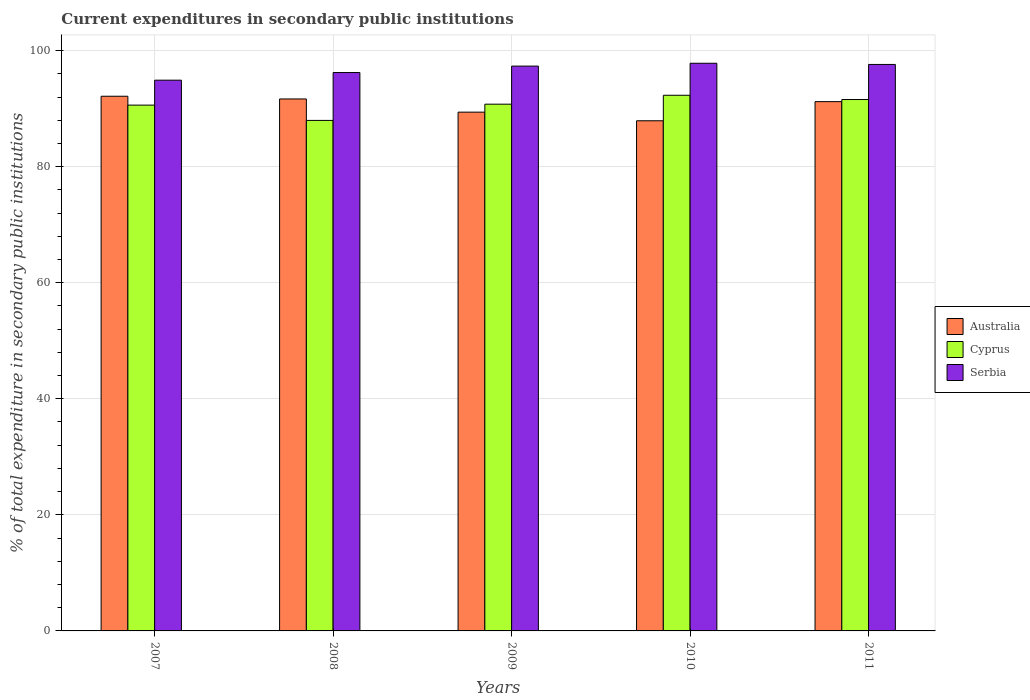Are the number of bars per tick equal to the number of legend labels?
Provide a succinct answer. Yes. How many bars are there on the 2nd tick from the left?
Your answer should be very brief. 3. What is the current expenditures in secondary public institutions in Cyprus in 2007?
Provide a short and direct response. 90.6. Across all years, what is the maximum current expenditures in secondary public institutions in Cyprus?
Ensure brevity in your answer.  92.3. Across all years, what is the minimum current expenditures in secondary public institutions in Australia?
Ensure brevity in your answer.  87.91. In which year was the current expenditures in secondary public institutions in Cyprus minimum?
Your answer should be very brief. 2008. What is the total current expenditures in secondary public institutions in Cyprus in the graph?
Offer a very short reply. 453.19. What is the difference between the current expenditures in secondary public institutions in Cyprus in 2008 and that in 2011?
Offer a very short reply. -3.6. What is the difference between the current expenditures in secondary public institutions in Serbia in 2011 and the current expenditures in secondary public institutions in Australia in 2009?
Your response must be concise. 8.22. What is the average current expenditures in secondary public institutions in Serbia per year?
Your answer should be very brief. 96.77. In the year 2011, what is the difference between the current expenditures in secondary public institutions in Cyprus and current expenditures in secondary public institutions in Australia?
Give a very brief answer. 0.36. What is the ratio of the current expenditures in secondary public institutions in Australia in 2007 to that in 2008?
Offer a terse response. 1.01. What is the difference between the highest and the second highest current expenditures in secondary public institutions in Cyprus?
Your response must be concise. 0.73. What is the difference between the highest and the lowest current expenditures in secondary public institutions in Serbia?
Your answer should be compact. 2.92. What does the 2nd bar from the left in 2009 represents?
Offer a very short reply. Cyprus. How many bars are there?
Provide a succinct answer. 15. How many years are there in the graph?
Give a very brief answer. 5. Are the values on the major ticks of Y-axis written in scientific E-notation?
Keep it short and to the point. No. Does the graph contain any zero values?
Make the answer very short. No. Does the graph contain grids?
Offer a terse response. Yes. How are the legend labels stacked?
Make the answer very short. Vertical. What is the title of the graph?
Ensure brevity in your answer.  Current expenditures in secondary public institutions. What is the label or title of the Y-axis?
Offer a very short reply. % of total expenditure in secondary public institutions. What is the % of total expenditure in secondary public institutions in Australia in 2007?
Your answer should be very brief. 92.13. What is the % of total expenditure in secondary public institutions of Cyprus in 2007?
Keep it short and to the point. 90.6. What is the % of total expenditure in secondary public institutions in Serbia in 2007?
Your answer should be very brief. 94.9. What is the % of total expenditure in secondary public institutions in Australia in 2008?
Make the answer very short. 91.66. What is the % of total expenditure in secondary public institutions in Cyprus in 2008?
Provide a succinct answer. 87.97. What is the % of total expenditure in secondary public institutions in Serbia in 2008?
Provide a short and direct response. 96.22. What is the % of total expenditure in secondary public institutions of Australia in 2009?
Offer a terse response. 89.39. What is the % of total expenditure in secondary public institutions in Cyprus in 2009?
Your response must be concise. 90.76. What is the % of total expenditure in secondary public institutions in Serbia in 2009?
Your answer should be very brief. 97.32. What is the % of total expenditure in secondary public institutions in Australia in 2010?
Your answer should be very brief. 87.91. What is the % of total expenditure in secondary public institutions in Cyprus in 2010?
Your answer should be very brief. 92.3. What is the % of total expenditure in secondary public institutions in Serbia in 2010?
Provide a succinct answer. 97.81. What is the % of total expenditure in secondary public institutions of Australia in 2011?
Your response must be concise. 91.2. What is the % of total expenditure in secondary public institutions in Cyprus in 2011?
Provide a succinct answer. 91.57. What is the % of total expenditure in secondary public institutions in Serbia in 2011?
Make the answer very short. 97.61. Across all years, what is the maximum % of total expenditure in secondary public institutions of Australia?
Ensure brevity in your answer.  92.13. Across all years, what is the maximum % of total expenditure in secondary public institutions in Cyprus?
Offer a terse response. 92.3. Across all years, what is the maximum % of total expenditure in secondary public institutions in Serbia?
Provide a succinct answer. 97.81. Across all years, what is the minimum % of total expenditure in secondary public institutions of Australia?
Offer a terse response. 87.91. Across all years, what is the minimum % of total expenditure in secondary public institutions of Cyprus?
Your response must be concise. 87.97. Across all years, what is the minimum % of total expenditure in secondary public institutions of Serbia?
Your answer should be compact. 94.9. What is the total % of total expenditure in secondary public institutions in Australia in the graph?
Make the answer very short. 452.29. What is the total % of total expenditure in secondary public institutions in Cyprus in the graph?
Keep it short and to the point. 453.19. What is the total % of total expenditure in secondary public institutions in Serbia in the graph?
Give a very brief answer. 483.86. What is the difference between the % of total expenditure in secondary public institutions of Australia in 2007 and that in 2008?
Offer a very short reply. 0.47. What is the difference between the % of total expenditure in secondary public institutions in Cyprus in 2007 and that in 2008?
Give a very brief answer. 2.64. What is the difference between the % of total expenditure in secondary public institutions of Serbia in 2007 and that in 2008?
Give a very brief answer. -1.32. What is the difference between the % of total expenditure in secondary public institutions of Australia in 2007 and that in 2009?
Offer a very short reply. 2.74. What is the difference between the % of total expenditure in secondary public institutions of Cyprus in 2007 and that in 2009?
Ensure brevity in your answer.  -0.16. What is the difference between the % of total expenditure in secondary public institutions of Serbia in 2007 and that in 2009?
Offer a very short reply. -2.42. What is the difference between the % of total expenditure in secondary public institutions in Australia in 2007 and that in 2010?
Give a very brief answer. 4.23. What is the difference between the % of total expenditure in secondary public institutions of Cyprus in 2007 and that in 2010?
Provide a short and direct response. -1.7. What is the difference between the % of total expenditure in secondary public institutions of Serbia in 2007 and that in 2010?
Your answer should be compact. -2.92. What is the difference between the % of total expenditure in secondary public institutions in Australia in 2007 and that in 2011?
Offer a very short reply. 0.93. What is the difference between the % of total expenditure in secondary public institutions in Cyprus in 2007 and that in 2011?
Your answer should be very brief. -0.96. What is the difference between the % of total expenditure in secondary public institutions of Serbia in 2007 and that in 2011?
Ensure brevity in your answer.  -2.71. What is the difference between the % of total expenditure in secondary public institutions in Australia in 2008 and that in 2009?
Provide a short and direct response. 2.27. What is the difference between the % of total expenditure in secondary public institutions of Cyprus in 2008 and that in 2009?
Your response must be concise. -2.8. What is the difference between the % of total expenditure in secondary public institutions in Serbia in 2008 and that in 2009?
Give a very brief answer. -1.11. What is the difference between the % of total expenditure in secondary public institutions in Australia in 2008 and that in 2010?
Make the answer very short. 3.76. What is the difference between the % of total expenditure in secondary public institutions in Cyprus in 2008 and that in 2010?
Give a very brief answer. -4.33. What is the difference between the % of total expenditure in secondary public institutions in Serbia in 2008 and that in 2010?
Your answer should be compact. -1.6. What is the difference between the % of total expenditure in secondary public institutions in Australia in 2008 and that in 2011?
Your answer should be very brief. 0.46. What is the difference between the % of total expenditure in secondary public institutions of Cyprus in 2008 and that in 2011?
Offer a terse response. -3.6. What is the difference between the % of total expenditure in secondary public institutions in Serbia in 2008 and that in 2011?
Provide a succinct answer. -1.39. What is the difference between the % of total expenditure in secondary public institutions of Australia in 2009 and that in 2010?
Provide a short and direct response. 1.49. What is the difference between the % of total expenditure in secondary public institutions of Cyprus in 2009 and that in 2010?
Ensure brevity in your answer.  -1.54. What is the difference between the % of total expenditure in secondary public institutions of Serbia in 2009 and that in 2010?
Provide a short and direct response. -0.49. What is the difference between the % of total expenditure in secondary public institutions in Australia in 2009 and that in 2011?
Provide a short and direct response. -1.81. What is the difference between the % of total expenditure in secondary public institutions in Cyprus in 2009 and that in 2011?
Provide a short and direct response. -0.8. What is the difference between the % of total expenditure in secondary public institutions of Serbia in 2009 and that in 2011?
Offer a very short reply. -0.29. What is the difference between the % of total expenditure in secondary public institutions of Australia in 2010 and that in 2011?
Keep it short and to the point. -3.3. What is the difference between the % of total expenditure in secondary public institutions of Cyprus in 2010 and that in 2011?
Your answer should be very brief. 0.73. What is the difference between the % of total expenditure in secondary public institutions of Serbia in 2010 and that in 2011?
Make the answer very short. 0.21. What is the difference between the % of total expenditure in secondary public institutions of Australia in 2007 and the % of total expenditure in secondary public institutions of Cyprus in 2008?
Provide a succinct answer. 4.17. What is the difference between the % of total expenditure in secondary public institutions of Australia in 2007 and the % of total expenditure in secondary public institutions of Serbia in 2008?
Provide a succinct answer. -4.09. What is the difference between the % of total expenditure in secondary public institutions in Cyprus in 2007 and the % of total expenditure in secondary public institutions in Serbia in 2008?
Provide a short and direct response. -5.62. What is the difference between the % of total expenditure in secondary public institutions in Australia in 2007 and the % of total expenditure in secondary public institutions in Cyprus in 2009?
Ensure brevity in your answer.  1.37. What is the difference between the % of total expenditure in secondary public institutions in Australia in 2007 and the % of total expenditure in secondary public institutions in Serbia in 2009?
Give a very brief answer. -5.19. What is the difference between the % of total expenditure in secondary public institutions of Cyprus in 2007 and the % of total expenditure in secondary public institutions of Serbia in 2009?
Provide a succinct answer. -6.72. What is the difference between the % of total expenditure in secondary public institutions of Australia in 2007 and the % of total expenditure in secondary public institutions of Cyprus in 2010?
Your response must be concise. -0.17. What is the difference between the % of total expenditure in secondary public institutions of Australia in 2007 and the % of total expenditure in secondary public institutions of Serbia in 2010?
Your response must be concise. -5.68. What is the difference between the % of total expenditure in secondary public institutions of Cyprus in 2007 and the % of total expenditure in secondary public institutions of Serbia in 2010?
Make the answer very short. -7.21. What is the difference between the % of total expenditure in secondary public institutions in Australia in 2007 and the % of total expenditure in secondary public institutions in Cyprus in 2011?
Keep it short and to the point. 0.57. What is the difference between the % of total expenditure in secondary public institutions in Australia in 2007 and the % of total expenditure in secondary public institutions in Serbia in 2011?
Your answer should be very brief. -5.48. What is the difference between the % of total expenditure in secondary public institutions in Cyprus in 2007 and the % of total expenditure in secondary public institutions in Serbia in 2011?
Give a very brief answer. -7.01. What is the difference between the % of total expenditure in secondary public institutions of Australia in 2008 and the % of total expenditure in secondary public institutions of Cyprus in 2009?
Your response must be concise. 0.9. What is the difference between the % of total expenditure in secondary public institutions in Australia in 2008 and the % of total expenditure in secondary public institutions in Serbia in 2009?
Keep it short and to the point. -5.66. What is the difference between the % of total expenditure in secondary public institutions of Cyprus in 2008 and the % of total expenditure in secondary public institutions of Serbia in 2009?
Provide a succinct answer. -9.36. What is the difference between the % of total expenditure in secondary public institutions of Australia in 2008 and the % of total expenditure in secondary public institutions of Cyprus in 2010?
Your answer should be compact. -0.64. What is the difference between the % of total expenditure in secondary public institutions in Australia in 2008 and the % of total expenditure in secondary public institutions in Serbia in 2010?
Give a very brief answer. -6.15. What is the difference between the % of total expenditure in secondary public institutions in Cyprus in 2008 and the % of total expenditure in secondary public institutions in Serbia in 2010?
Make the answer very short. -9.85. What is the difference between the % of total expenditure in secondary public institutions of Australia in 2008 and the % of total expenditure in secondary public institutions of Cyprus in 2011?
Your answer should be compact. 0.1. What is the difference between the % of total expenditure in secondary public institutions in Australia in 2008 and the % of total expenditure in secondary public institutions in Serbia in 2011?
Provide a short and direct response. -5.95. What is the difference between the % of total expenditure in secondary public institutions of Cyprus in 2008 and the % of total expenditure in secondary public institutions of Serbia in 2011?
Provide a succinct answer. -9.64. What is the difference between the % of total expenditure in secondary public institutions in Australia in 2009 and the % of total expenditure in secondary public institutions in Cyprus in 2010?
Ensure brevity in your answer.  -2.91. What is the difference between the % of total expenditure in secondary public institutions of Australia in 2009 and the % of total expenditure in secondary public institutions of Serbia in 2010?
Keep it short and to the point. -8.42. What is the difference between the % of total expenditure in secondary public institutions of Cyprus in 2009 and the % of total expenditure in secondary public institutions of Serbia in 2010?
Offer a very short reply. -7.05. What is the difference between the % of total expenditure in secondary public institutions of Australia in 2009 and the % of total expenditure in secondary public institutions of Cyprus in 2011?
Your answer should be compact. -2.17. What is the difference between the % of total expenditure in secondary public institutions in Australia in 2009 and the % of total expenditure in secondary public institutions in Serbia in 2011?
Your response must be concise. -8.22. What is the difference between the % of total expenditure in secondary public institutions in Cyprus in 2009 and the % of total expenditure in secondary public institutions in Serbia in 2011?
Offer a terse response. -6.85. What is the difference between the % of total expenditure in secondary public institutions in Australia in 2010 and the % of total expenditure in secondary public institutions in Cyprus in 2011?
Keep it short and to the point. -3.66. What is the difference between the % of total expenditure in secondary public institutions of Australia in 2010 and the % of total expenditure in secondary public institutions of Serbia in 2011?
Your answer should be compact. -9.7. What is the difference between the % of total expenditure in secondary public institutions of Cyprus in 2010 and the % of total expenditure in secondary public institutions of Serbia in 2011?
Keep it short and to the point. -5.31. What is the average % of total expenditure in secondary public institutions of Australia per year?
Keep it short and to the point. 90.46. What is the average % of total expenditure in secondary public institutions in Cyprus per year?
Your answer should be very brief. 90.64. What is the average % of total expenditure in secondary public institutions of Serbia per year?
Your answer should be very brief. 96.77. In the year 2007, what is the difference between the % of total expenditure in secondary public institutions in Australia and % of total expenditure in secondary public institutions in Cyprus?
Keep it short and to the point. 1.53. In the year 2007, what is the difference between the % of total expenditure in secondary public institutions in Australia and % of total expenditure in secondary public institutions in Serbia?
Your answer should be very brief. -2.77. In the year 2007, what is the difference between the % of total expenditure in secondary public institutions of Cyprus and % of total expenditure in secondary public institutions of Serbia?
Your answer should be very brief. -4.3. In the year 2008, what is the difference between the % of total expenditure in secondary public institutions of Australia and % of total expenditure in secondary public institutions of Cyprus?
Make the answer very short. 3.7. In the year 2008, what is the difference between the % of total expenditure in secondary public institutions in Australia and % of total expenditure in secondary public institutions in Serbia?
Offer a very short reply. -4.55. In the year 2008, what is the difference between the % of total expenditure in secondary public institutions of Cyprus and % of total expenditure in secondary public institutions of Serbia?
Provide a succinct answer. -8.25. In the year 2009, what is the difference between the % of total expenditure in secondary public institutions in Australia and % of total expenditure in secondary public institutions in Cyprus?
Provide a succinct answer. -1.37. In the year 2009, what is the difference between the % of total expenditure in secondary public institutions of Australia and % of total expenditure in secondary public institutions of Serbia?
Give a very brief answer. -7.93. In the year 2009, what is the difference between the % of total expenditure in secondary public institutions in Cyprus and % of total expenditure in secondary public institutions in Serbia?
Make the answer very short. -6.56. In the year 2010, what is the difference between the % of total expenditure in secondary public institutions of Australia and % of total expenditure in secondary public institutions of Cyprus?
Provide a short and direct response. -4.39. In the year 2010, what is the difference between the % of total expenditure in secondary public institutions in Australia and % of total expenditure in secondary public institutions in Serbia?
Give a very brief answer. -9.91. In the year 2010, what is the difference between the % of total expenditure in secondary public institutions of Cyprus and % of total expenditure in secondary public institutions of Serbia?
Give a very brief answer. -5.52. In the year 2011, what is the difference between the % of total expenditure in secondary public institutions in Australia and % of total expenditure in secondary public institutions in Cyprus?
Provide a short and direct response. -0.36. In the year 2011, what is the difference between the % of total expenditure in secondary public institutions of Australia and % of total expenditure in secondary public institutions of Serbia?
Make the answer very short. -6.41. In the year 2011, what is the difference between the % of total expenditure in secondary public institutions of Cyprus and % of total expenditure in secondary public institutions of Serbia?
Your answer should be compact. -6.04. What is the ratio of the % of total expenditure in secondary public institutions of Cyprus in 2007 to that in 2008?
Your answer should be very brief. 1.03. What is the ratio of the % of total expenditure in secondary public institutions in Serbia in 2007 to that in 2008?
Keep it short and to the point. 0.99. What is the ratio of the % of total expenditure in secondary public institutions in Australia in 2007 to that in 2009?
Keep it short and to the point. 1.03. What is the ratio of the % of total expenditure in secondary public institutions of Serbia in 2007 to that in 2009?
Your answer should be very brief. 0.98. What is the ratio of the % of total expenditure in secondary public institutions of Australia in 2007 to that in 2010?
Provide a succinct answer. 1.05. What is the ratio of the % of total expenditure in secondary public institutions in Cyprus in 2007 to that in 2010?
Offer a very short reply. 0.98. What is the ratio of the % of total expenditure in secondary public institutions of Serbia in 2007 to that in 2010?
Ensure brevity in your answer.  0.97. What is the ratio of the % of total expenditure in secondary public institutions in Australia in 2007 to that in 2011?
Give a very brief answer. 1.01. What is the ratio of the % of total expenditure in secondary public institutions of Serbia in 2007 to that in 2011?
Give a very brief answer. 0.97. What is the ratio of the % of total expenditure in secondary public institutions in Australia in 2008 to that in 2009?
Provide a succinct answer. 1.03. What is the ratio of the % of total expenditure in secondary public institutions in Cyprus in 2008 to that in 2009?
Your answer should be compact. 0.97. What is the ratio of the % of total expenditure in secondary public institutions in Australia in 2008 to that in 2010?
Provide a short and direct response. 1.04. What is the ratio of the % of total expenditure in secondary public institutions of Cyprus in 2008 to that in 2010?
Your answer should be very brief. 0.95. What is the ratio of the % of total expenditure in secondary public institutions of Serbia in 2008 to that in 2010?
Keep it short and to the point. 0.98. What is the ratio of the % of total expenditure in secondary public institutions in Australia in 2008 to that in 2011?
Your answer should be compact. 1.01. What is the ratio of the % of total expenditure in secondary public institutions in Cyprus in 2008 to that in 2011?
Give a very brief answer. 0.96. What is the ratio of the % of total expenditure in secondary public institutions of Serbia in 2008 to that in 2011?
Ensure brevity in your answer.  0.99. What is the ratio of the % of total expenditure in secondary public institutions of Australia in 2009 to that in 2010?
Your answer should be compact. 1.02. What is the ratio of the % of total expenditure in secondary public institutions in Cyprus in 2009 to that in 2010?
Your response must be concise. 0.98. What is the ratio of the % of total expenditure in secondary public institutions of Serbia in 2009 to that in 2010?
Your response must be concise. 0.99. What is the ratio of the % of total expenditure in secondary public institutions of Australia in 2009 to that in 2011?
Your answer should be compact. 0.98. What is the ratio of the % of total expenditure in secondary public institutions of Cyprus in 2009 to that in 2011?
Your response must be concise. 0.99. What is the ratio of the % of total expenditure in secondary public institutions of Australia in 2010 to that in 2011?
Make the answer very short. 0.96. What is the ratio of the % of total expenditure in secondary public institutions of Cyprus in 2010 to that in 2011?
Offer a very short reply. 1.01. What is the difference between the highest and the second highest % of total expenditure in secondary public institutions in Australia?
Provide a succinct answer. 0.47. What is the difference between the highest and the second highest % of total expenditure in secondary public institutions in Cyprus?
Offer a very short reply. 0.73. What is the difference between the highest and the second highest % of total expenditure in secondary public institutions of Serbia?
Your answer should be very brief. 0.21. What is the difference between the highest and the lowest % of total expenditure in secondary public institutions in Australia?
Offer a very short reply. 4.23. What is the difference between the highest and the lowest % of total expenditure in secondary public institutions of Cyprus?
Offer a terse response. 4.33. What is the difference between the highest and the lowest % of total expenditure in secondary public institutions in Serbia?
Provide a short and direct response. 2.92. 